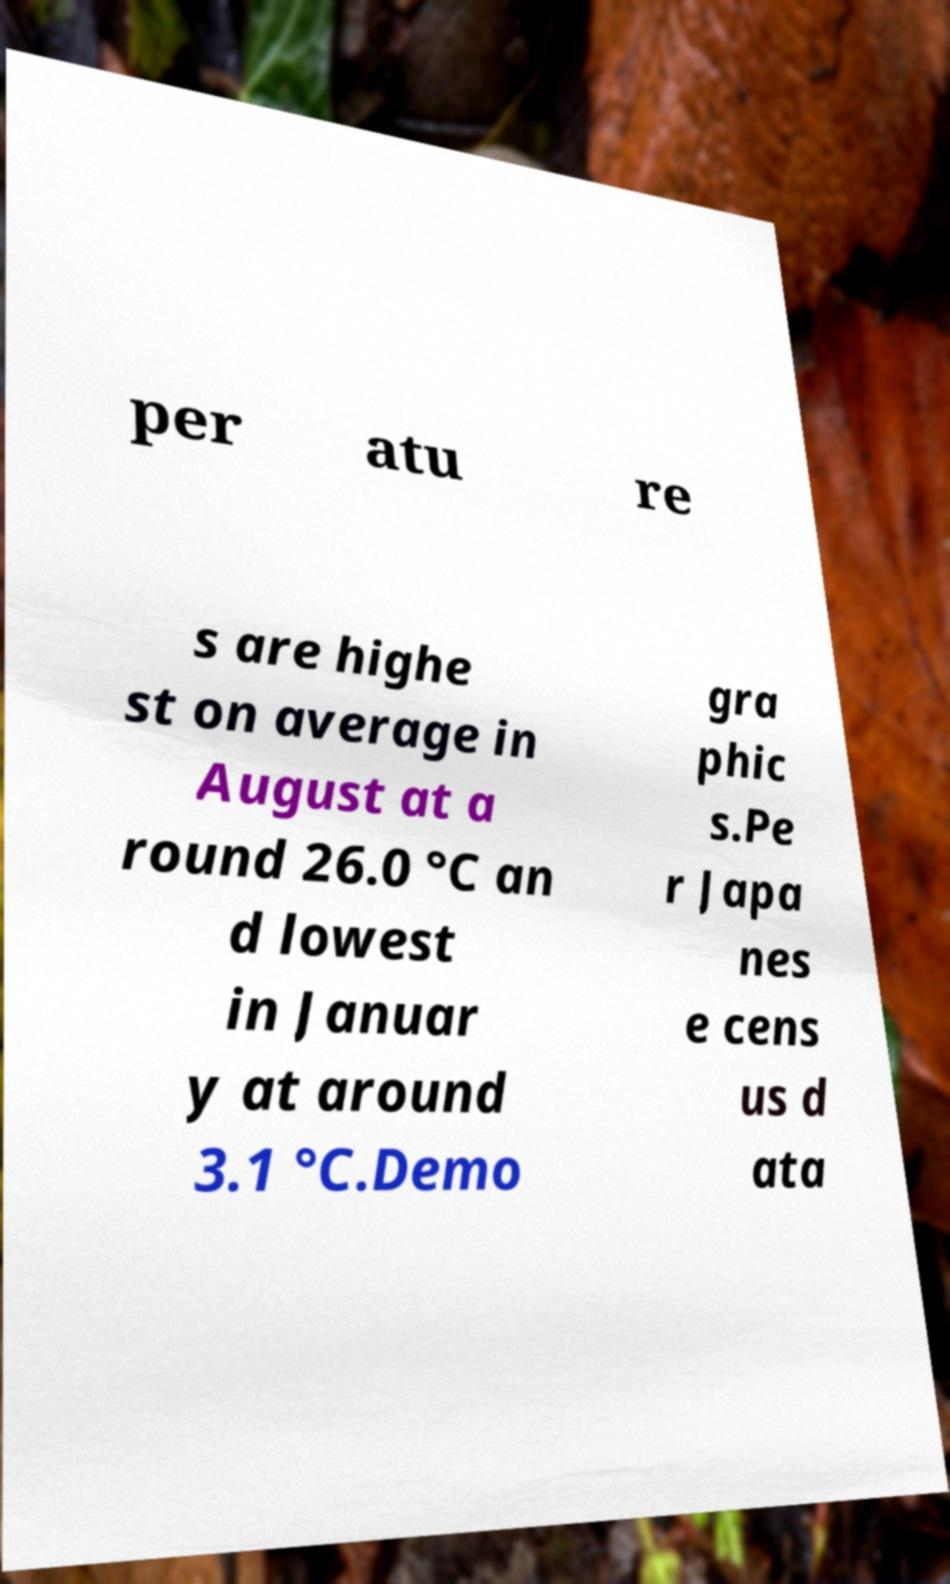There's text embedded in this image that I need extracted. Can you transcribe it verbatim? per atu re s are highe st on average in August at a round 26.0 °C an d lowest in Januar y at around 3.1 °C.Demo gra phic s.Pe r Japa nes e cens us d ata 